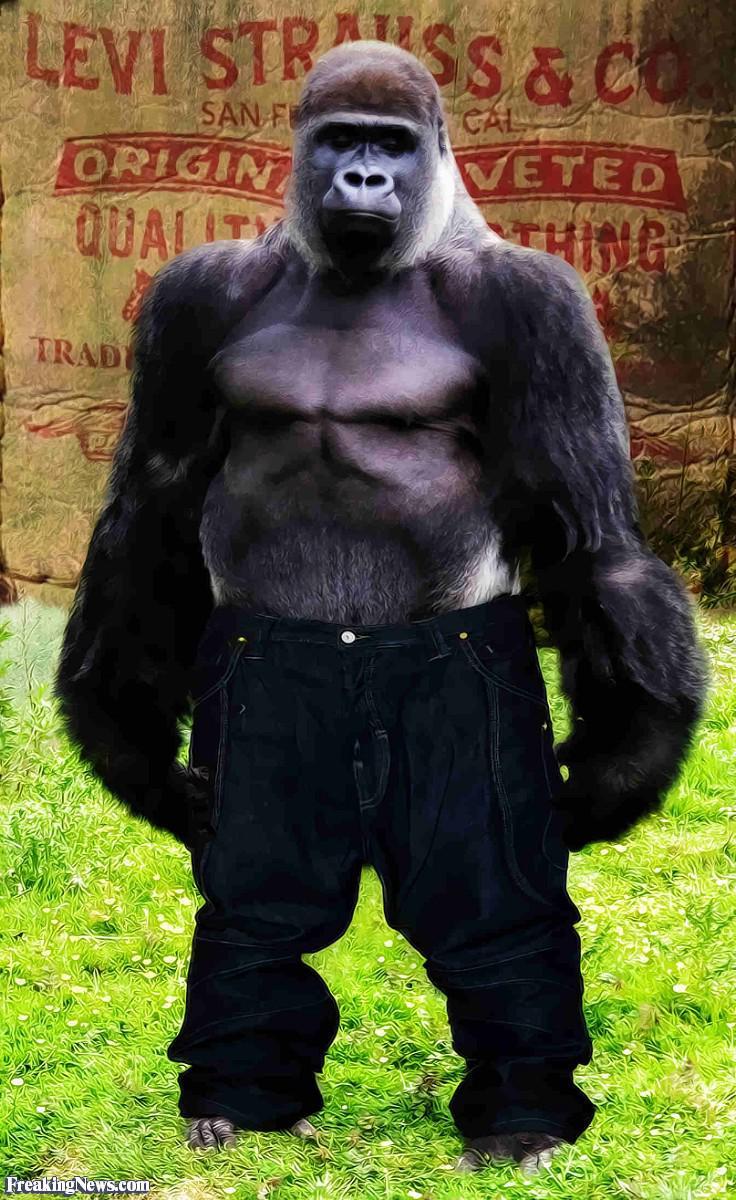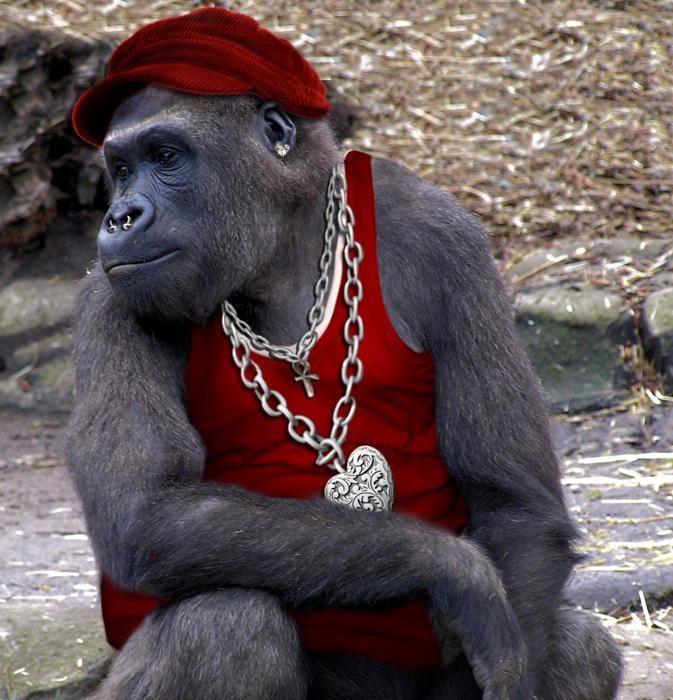The first image is the image on the left, the second image is the image on the right. Analyze the images presented: Is the assertion "A gorilla is shown with an item of clothing in each image." valid? Answer yes or no. Yes. 